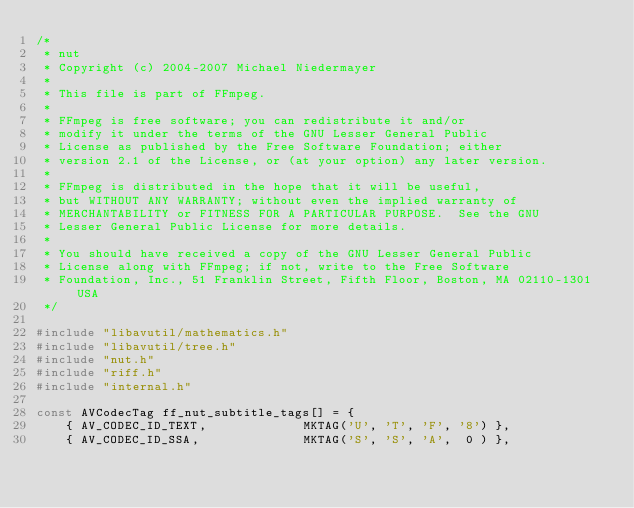Convert code to text. <code><loc_0><loc_0><loc_500><loc_500><_C_>/*
 * nut
 * Copyright (c) 2004-2007 Michael Niedermayer
 *
 * This file is part of FFmpeg.
 *
 * FFmpeg is free software; you can redistribute it and/or
 * modify it under the terms of the GNU Lesser General Public
 * License as published by the Free Software Foundation; either
 * version 2.1 of the License, or (at your option) any later version.
 *
 * FFmpeg is distributed in the hope that it will be useful,
 * but WITHOUT ANY WARRANTY; without even the implied warranty of
 * MERCHANTABILITY or FITNESS FOR A PARTICULAR PURPOSE.  See the GNU
 * Lesser General Public License for more details.
 *
 * You should have received a copy of the GNU Lesser General Public
 * License along with FFmpeg; if not, write to the Free Software
 * Foundation, Inc., 51 Franklin Street, Fifth Floor, Boston, MA 02110-1301 USA
 */

#include "libavutil/mathematics.h"
#include "libavutil/tree.h"
#include "nut.h"
#include "riff.h"
#include "internal.h"

const AVCodecTag ff_nut_subtitle_tags[] = {
    { AV_CODEC_ID_TEXT,             MKTAG('U', 'T', 'F', '8') },
    { AV_CODEC_ID_SSA,              MKTAG('S', 'S', 'A',  0 ) },</code> 